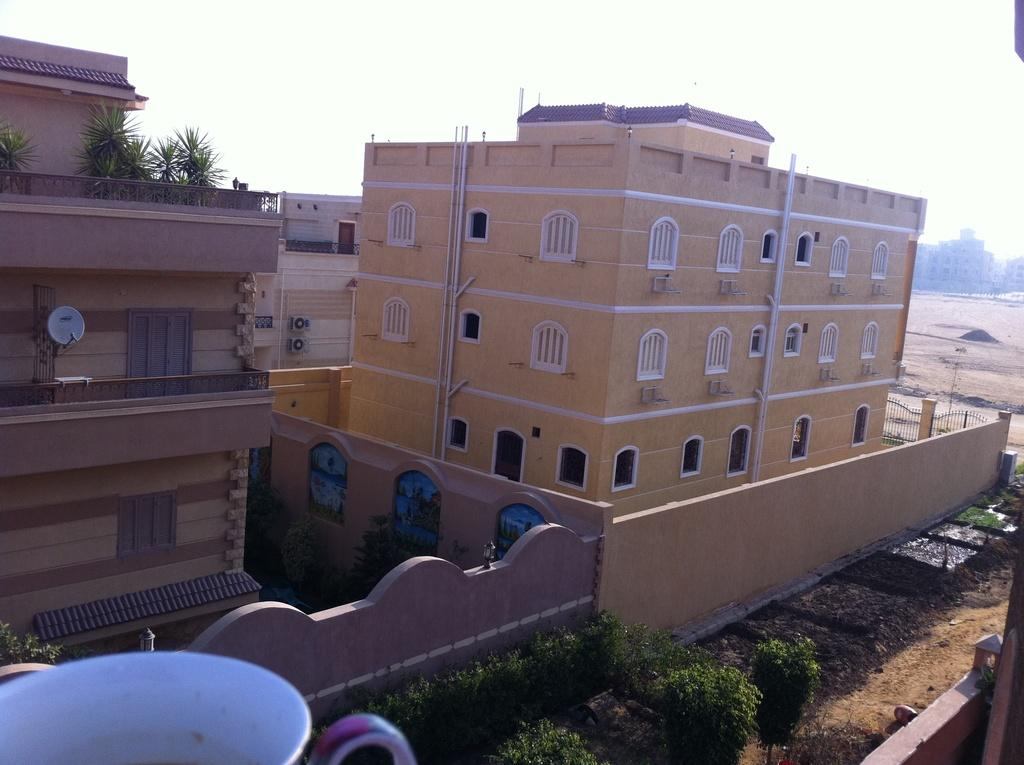What type of natural elements can be seen in the image? There are trees in the image. What type of man-made structures are present in the image? There are buildings in the image. What type of illumination is visible in the image? There are lights in the image. What type of infrastructure is present on the walls in the image? There are pipes on the walls in the image. Where is the cup located in the image? The cup is in the bottom left hand corner of the image. How many boys are playing with the toy sheep in the image? There are no boys or toy sheep present in the image. What type of design is featured on the cup in the image? The provided facts do not mention any specific design on the cup, so we cannot answer this question. 